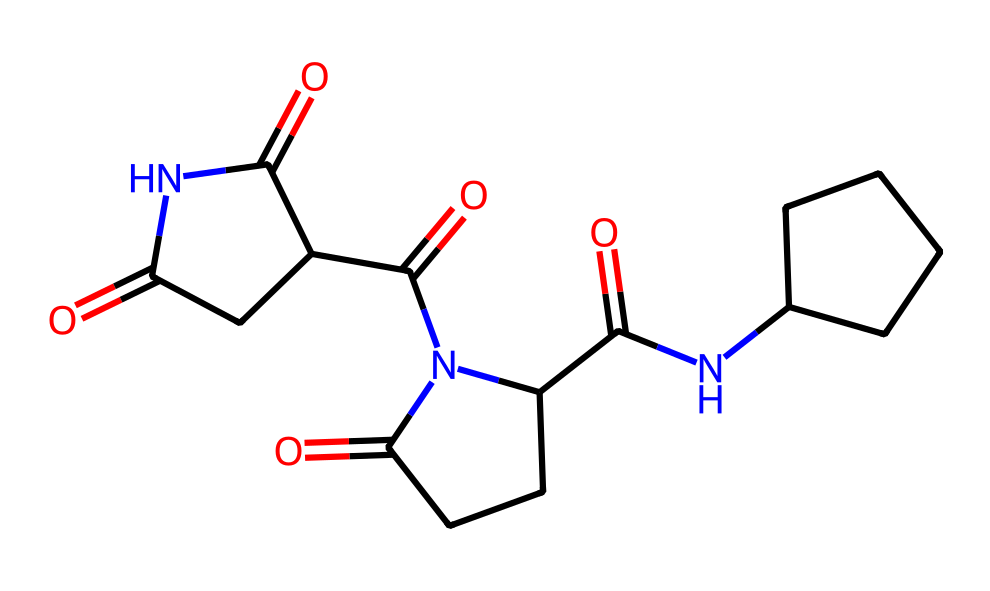What is the chemical name of this compound? The structure corresponds to thalidomide, a well-known pharmaceutical agent with historical significance.
Answer: thalidomide How many chiral centers are present in this compound? By analyzing the structure, there are two carbon atoms bonded to four different substituents, which identifies them as chiral centers.
Answer: two What functional groups are present in this molecule? Upon examination of the structure, it contains ketone (C=O) and amide (C(=O)N) functional groups.
Answer: ketone and amide What is the potential effect of the enantiomers of this drug? The S-enantiomer is effective as a sedative, while the R-enantiomer has been associated with severe birth defects, highlighting the importance of chirality.
Answer: sedation and birth defects Is thalidomide considered a chiral compound? Yes, thalidomide has stereoisomeric forms due to its chiral centers; its different enantiomers exhibit distinct biological activities.
Answer: yes How many total carbon atoms are in the structure? By counting the carbon atoms in the skeletal structure, one can identify thirteen total carbon atoms.
Answer: thirteen 